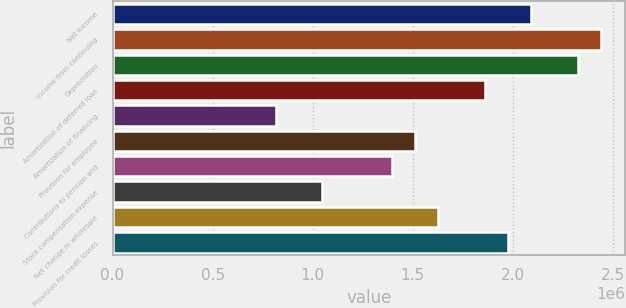Convert chart to OTSL. <chart><loc_0><loc_0><loc_500><loc_500><bar_chart><fcel>Net income<fcel>Income from continuing<fcel>Depreciation<fcel>Amortization of deferred loan<fcel>Amortization of financing<fcel>Provision for employee<fcel>Contributions to pension and<fcel>Stock compensation expense<fcel>Net change in wholesale<fcel>Provision for credit losses<nl><fcel>2.09214e+06<fcel>2.44041e+06<fcel>2.32432e+06<fcel>1.85996e+06<fcel>815147<fcel>1.51169e+06<fcel>1.3956e+06<fcel>1.04733e+06<fcel>1.62778e+06<fcel>1.97605e+06<nl></chart> 